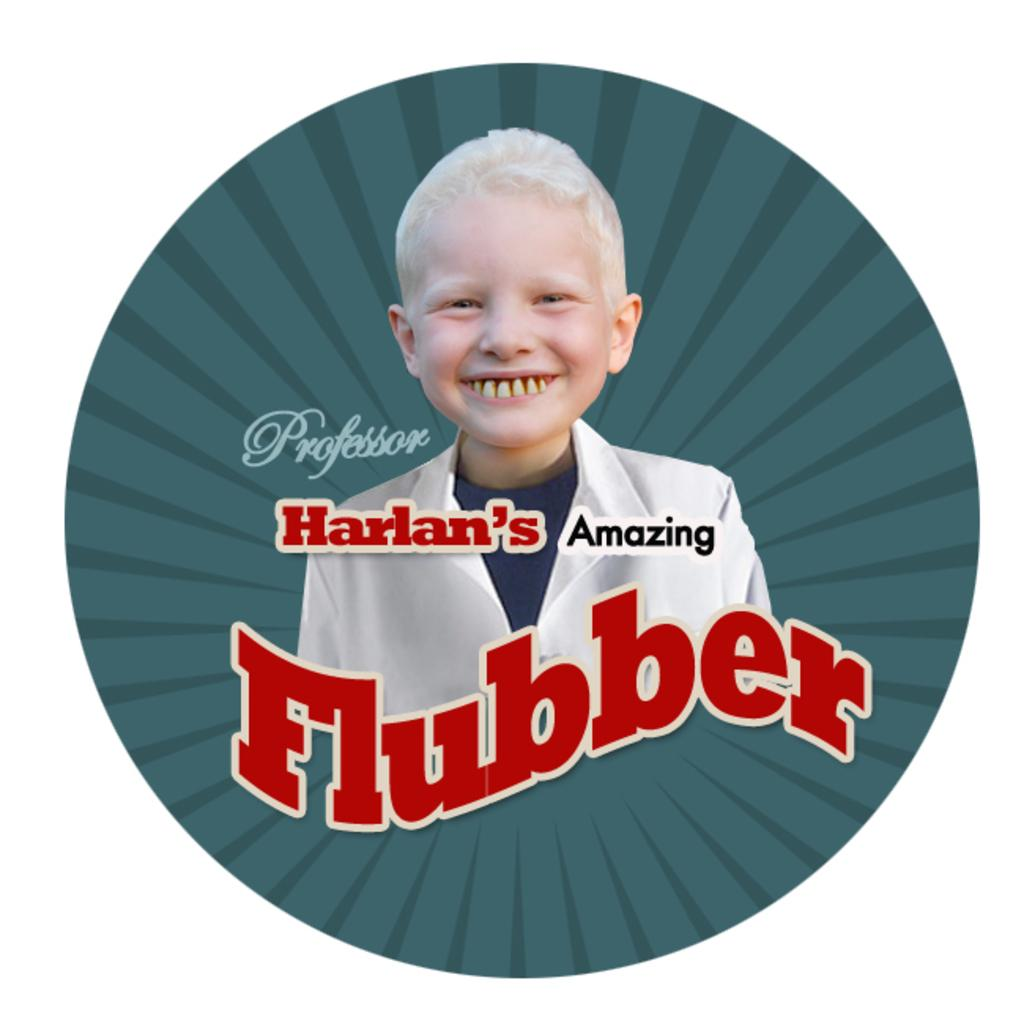<image>
Render a clear and concise summary of the photo. A boy with a large smile on a sticker advertising Professor Harlan's Amazing Flubber. 